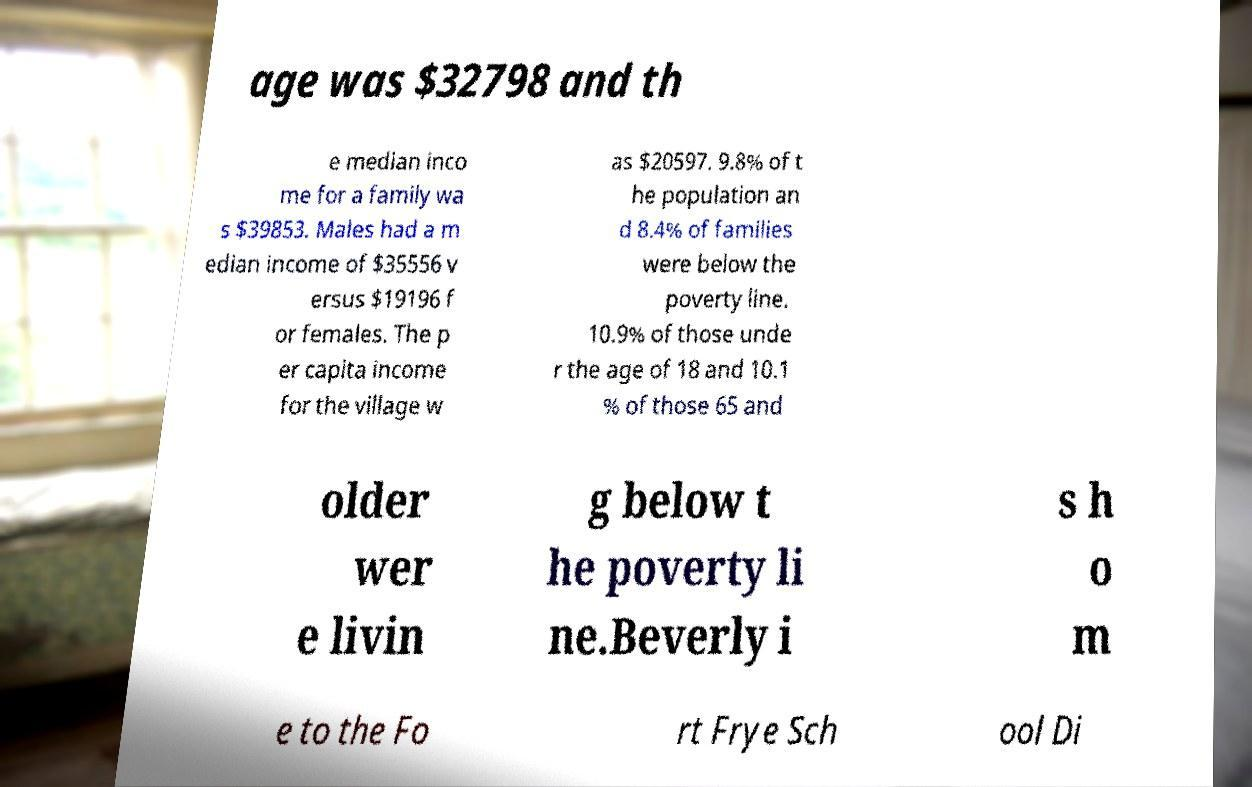Can you accurately transcribe the text from the provided image for me? age was $32798 and th e median inco me for a family wa s $39853. Males had a m edian income of $35556 v ersus $19196 f or females. The p er capita income for the village w as $20597. 9.8% of t he population an d 8.4% of families were below the poverty line. 10.9% of those unde r the age of 18 and 10.1 % of those 65 and older wer e livin g below t he poverty li ne.Beverly i s h o m e to the Fo rt Frye Sch ool Di 